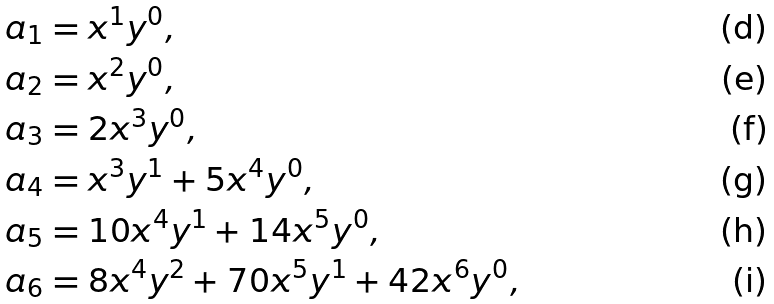Convert formula to latex. <formula><loc_0><loc_0><loc_500><loc_500>a _ { 1 } & = x ^ { 1 } y ^ { 0 } , \\ a _ { 2 } & = x ^ { 2 } y ^ { 0 } , \\ a _ { 3 } & = 2 x ^ { 3 } y ^ { 0 } , \\ a _ { 4 } & = x ^ { 3 } y ^ { 1 } + 5 x ^ { 4 } y ^ { 0 } , \\ a _ { 5 } & = 1 0 x ^ { 4 } y ^ { 1 } + 1 4 x ^ { 5 } y ^ { 0 } , \\ a _ { 6 } & = 8 x ^ { 4 } y ^ { 2 } + 7 0 x ^ { 5 } y ^ { 1 } + 4 2 x ^ { 6 } y ^ { 0 } ,</formula> 